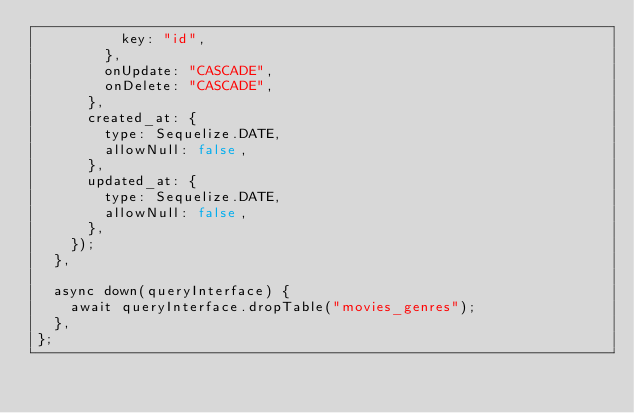Convert code to text. <code><loc_0><loc_0><loc_500><loc_500><_JavaScript_>          key: "id",
        },
        onUpdate: "CASCADE",
        onDelete: "CASCADE",
      },
      created_at: {
        type: Sequelize.DATE,
        allowNull: false,
      },
      updated_at: {
        type: Sequelize.DATE,
        allowNull: false,
      },
    });
  },

  async down(queryInterface) {
    await queryInterface.dropTable("movies_genres");
  },
};
</code> 